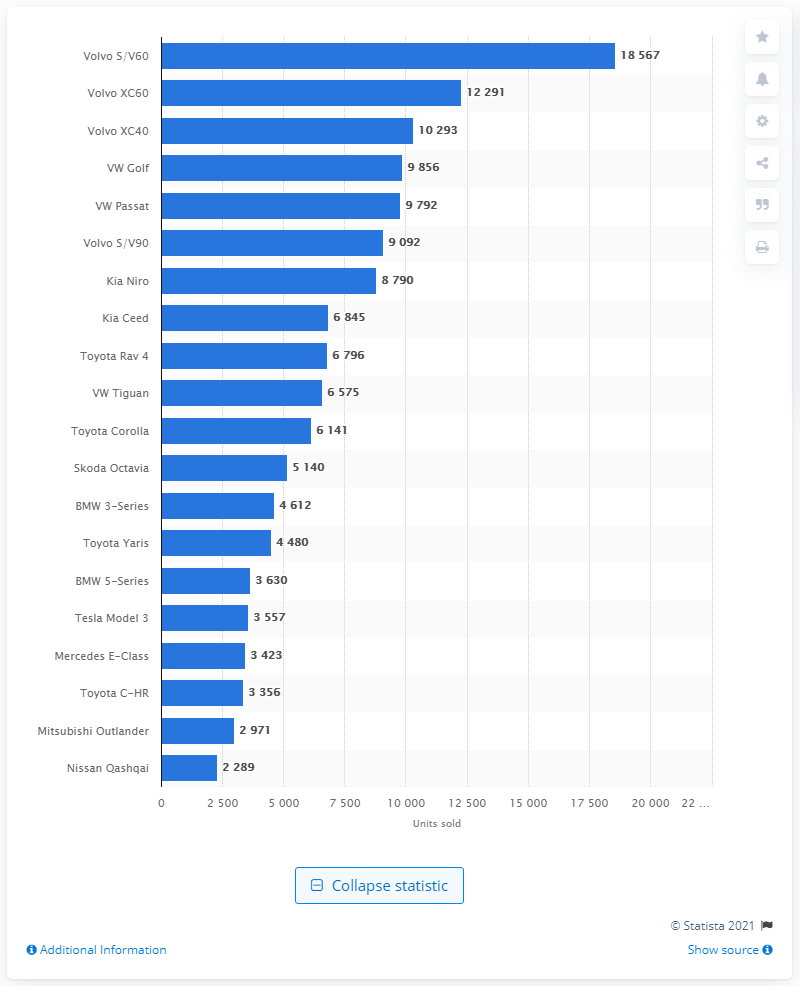Outline some significant characteristics in this image. The sales amount of the Volvo XC40 in Sweden in 2020 was 12,291 units. Last year, a total of 12,291 units of the S/V60 and XC60 were sold in Sweden. 